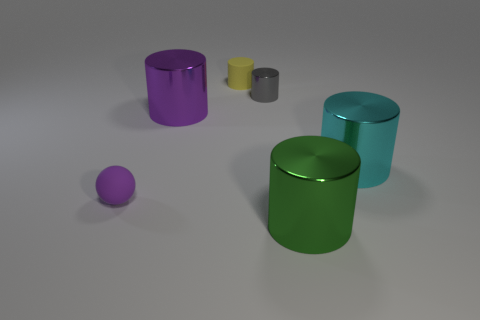The purple thing that is the same shape as the large cyan metal thing is what size? The purple object, which has a cylindrical shape identical to the large cyan object, is significantly smaller in size. While the exact dimensions are not available, visual comparison suggests the purple object is roughly less than half the height and diameter of the large cyan cylinder. 